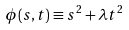Convert formula to latex. <formula><loc_0><loc_0><loc_500><loc_500>\phi ( s , t ) \equiv s ^ { 2 } + \lambda t ^ { 2 }</formula> 